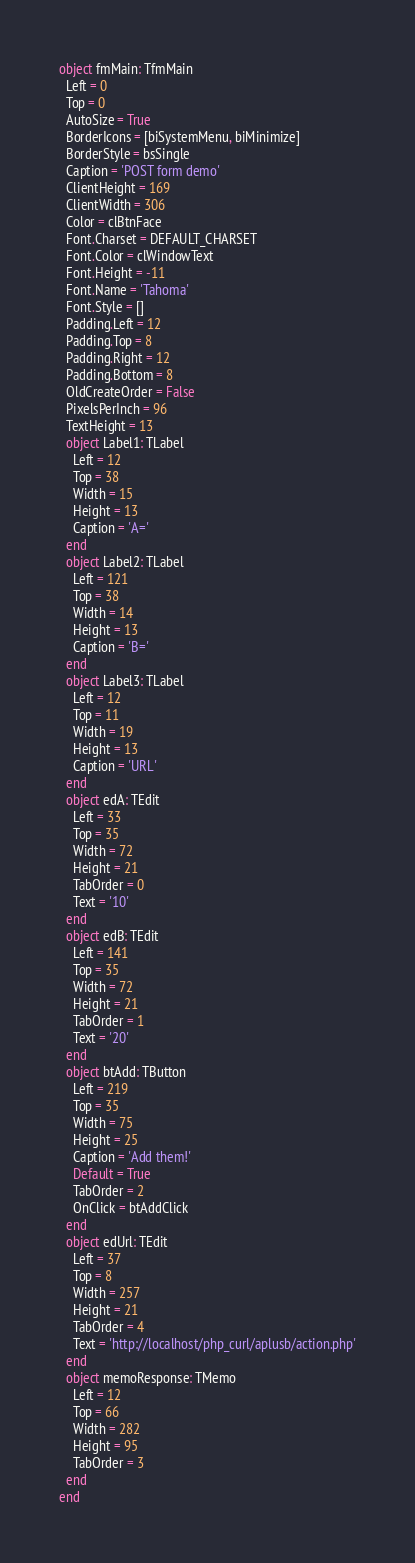Convert code to text. <code><loc_0><loc_0><loc_500><loc_500><_Pascal_>object fmMain: TfmMain
  Left = 0
  Top = 0
  AutoSize = True
  BorderIcons = [biSystemMenu, biMinimize]
  BorderStyle = bsSingle
  Caption = 'POST form demo'
  ClientHeight = 169
  ClientWidth = 306
  Color = clBtnFace
  Font.Charset = DEFAULT_CHARSET
  Font.Color = clWindowText
  Font.Height = -11
  Font.Name = 'Tahoma'
  Font.Style = []
  Padding.Left = 12
  Padding.Top = 8
  Padding.Right = 12
  Padding.Bottom = 8
  OldCreateOrder = False
  PixelsPerInch = 96
  TextHeight = 13
  object Label1: TLabel
    Left = 12
    Top = 38
    Width = 15
    Height = 13
    Caption = 'A='
  end
  object Label2: TLabel
    Left = 121
    Top = 38
    Width = 14
    Height = 13
    Caption = 'B='
  end
  object Label3: TLabel
    Left = 12
    Top = 11
    Width = 19
    Height = 13
    Caption = 'URL'
  end
  object edA: TEdit
    Left = 33
    Top = 35
    Width = 72
    Height = 21
    TabOrder = 0
    Text = '10'
  end
  object edB: TEdit
    Left = 141
    Top = 35
    Width = 72
    Height = 21
    TabOrder = 1
    Text = '20'
  end
  object btAdd: TButton
    Left = 219
    Top = 35
    Width = 75
    Height = 25
    Caption = 'Add them!'
    Default = True
    TabOrder = 2
    OnClick = btAddClick
  end
  object edUrl: TEdit
    Left = 37
    Top = 8
    Width = 257
    Height = 21
    TabOrder = 4
    Text = 'http://localhost/php_curl/aplusb/action.php'
  end
  object memoResponse: TMemo
    Left = 12
    Top = 66
    Width = 282
    Height = 95
    TabOrder = 3
  end
end
</code> 